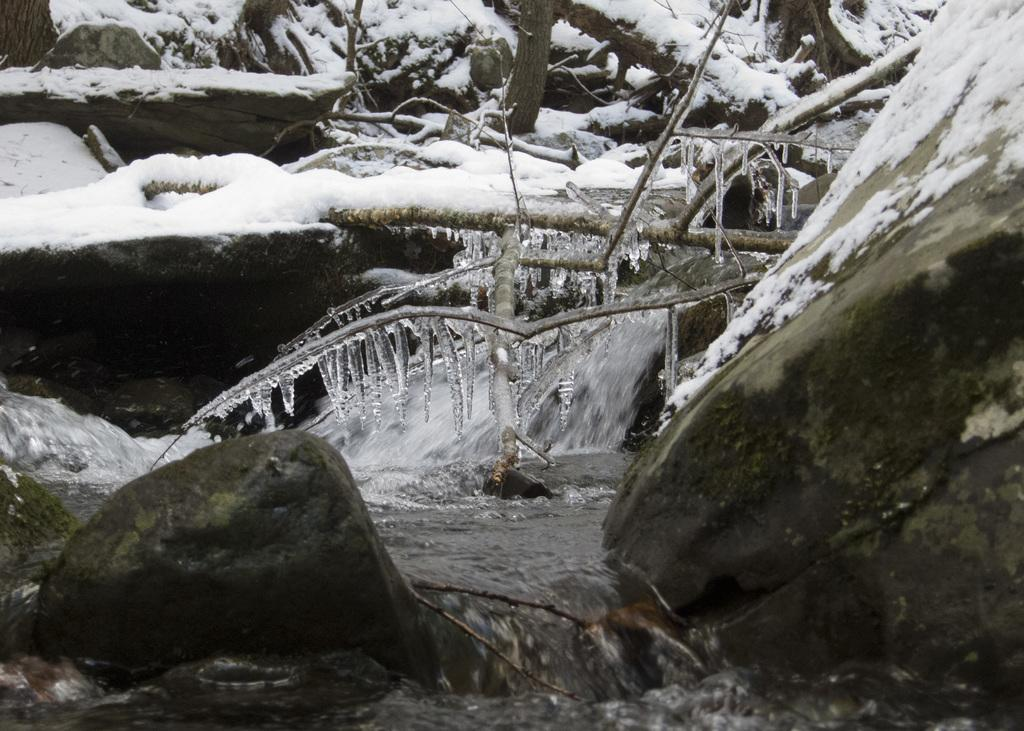What is the main feature in the center of the image? There are trees in the center of the image. What is the condition of the ground in the image? There is snow and water in the image, indicating that the ground is covered in snow and water. What can be seen on the trees in the image? There are branches visible on the trees in the image. Can you describe any other objects in the image? There are a few other objects in the image, but their specific details are not mentioned in the provided facts. What type of stocking is hanging from the tree in the image? There is no stocking hanging from the tree in the image. How many birds can be seen perched on the branches in the image? There are no birds visible in the image. 